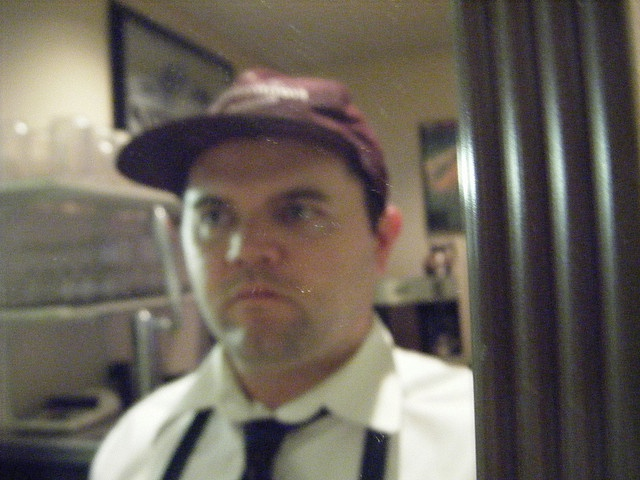Describe the objects in this image and their specific colors. I can see people in gray, ivory, and darkgray tones, cup in gray, beige, and tan tones, and tie in gray, black, navy, and darkgreen tones in this image. 